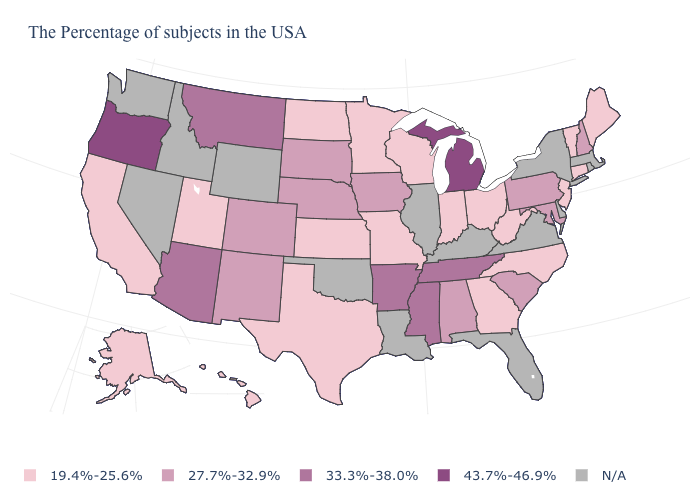How many symbols are there in the legend?
Short answer required. 5. What is the value of Idaho?
Keep it brief. N/A. Which states hav the highest value in the West?
Keep it brief. Oregon. What is the value of Wyoming?
Be succinct. N/A. Name the states that have a value in the range 27.7%-32.9%?
Concise answer only. New Hampshire, Maryland, Pennsylvania, South Carolina, Alabama, Iowa, Nebraska, South Dakota, Colorado, New Mexico. Which states have the lowest value in the USA?
Answer briefly. Maine, Vermont, Connecticut, New Jersey, North Carolina, West Virginia, Ohio, Georgia, Indiana, Wisconsin, Missouri, Minnesota, Kansas, Texas, North Dakota, Utah, California, Alaska, Hawaii. Which states have the lowest value in the West?
Quick response, please. Utah, California, Alaska, Hawaii. Does the map have missing data?
Give a very brief answer. Yes. Does Michigan have the highest value in the USA?
Give a very brief answer. Yes. Among the states that border Nevada , which have the lowest value?
Short answer required. Utah, California. What is the value of Nebraska?
Answer briefly. 27.7%-32.9%. 